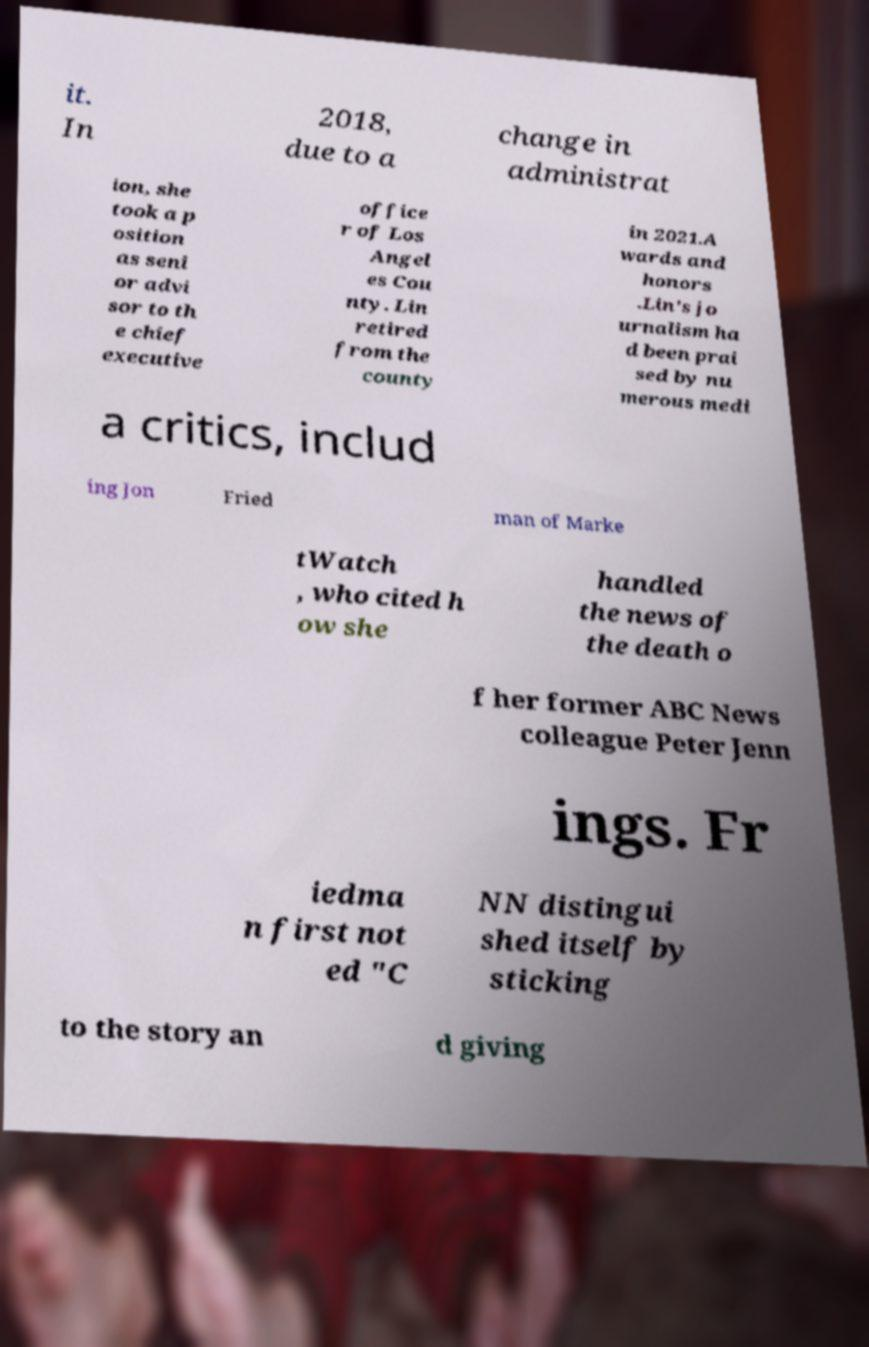Please read and relay the text visible in this image. What does it say? it. In 2018, due to a change in administrat ion, she took a p osition as seni or advi sor to th e chief executive office r of Los Angel es Cou nty. Lin retired from the county in 2021.A wards and honors .Lin's jo urnalism ha d been prai sed by nu merous medi a critics, includ ing Jon Fried man of Marke tWatch , who cited h ow she handled the news of the death o f her former ABC News colleague Peter Jenn ings. Fr iedma n first not ed "C NN distingui shed itself by sticking to the story an d giving 